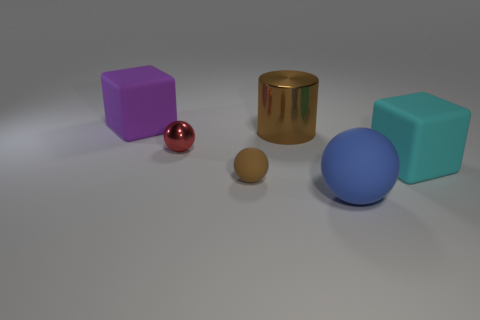Imagine this is a scene from a story. Can you narrate what might be happening? In a realm where geometry and color govern the laws of physics, five sentient shapes embark on a quest to align according to the prophecy of The Great Pattern. Their journey is fraught with challenges, as they must navigate the flatland and find their rightful place in the grand design. 